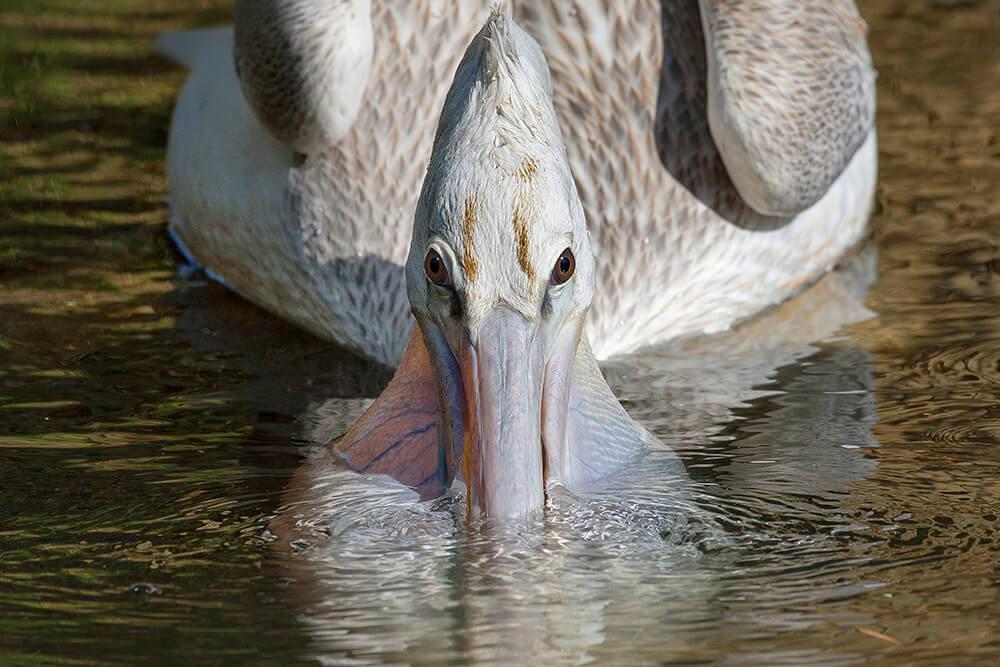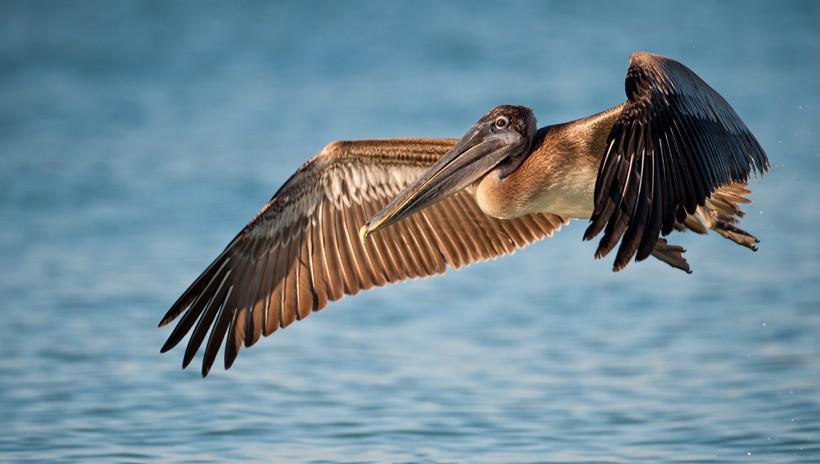The first image is the image on the left, the second image is the image on the right. For the images displayed, is the sentence "There are more pelican birds in the right image than in the left." factually correct? Answer yes or no. No. The first image is the image on the left, the second image is the image on the right. Evaluate the accuracy of this statement regarding the images: "The bird in the image on the left is flying.". Is it true? Answer yes or no. No. 